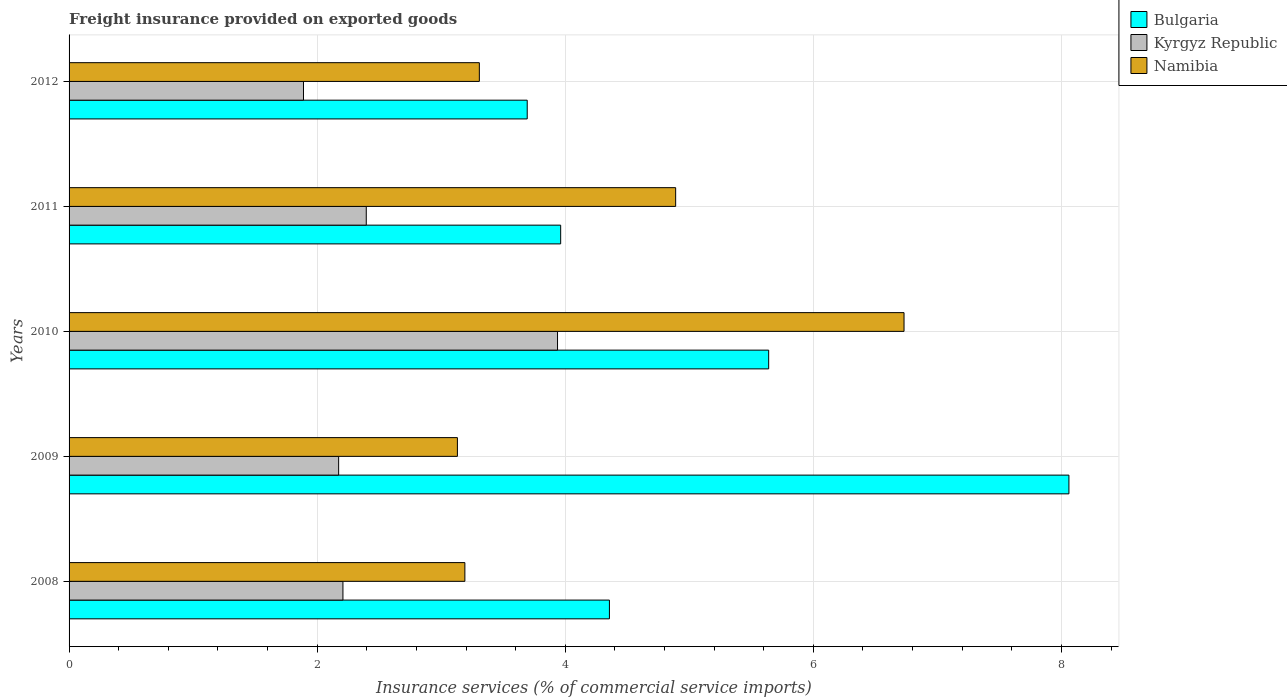How many groups of bars are there?
Keep it short and to the point. 5. Are the number of bars per tick equal to the number of legend labels?
Your answer should be very brief. Yes. Are the number of bars on each tick of the Y-axis equal?
Offer a terse response. Yes. How many bars are there on the 4th tick from the bottom?
Your answer should be very brief. 3. What is the freight insurance provided on exported goods in Namibia in 2011?
Provide a short and direct response. 4.89. Across all years, what is the maximum freight insurance provided on exported goods in Kyrgyz Republic?
Ensure brevity in your answer.  3.94. Across all years, what is the minimum freight insurance provided on exported goods in Bulgaria?
Your answer should be very brief. 3.69. In which year was the freight insurance provided on exported goods in Bulgaria maximum?
Your response must be concise. 2009. In which year was the freight insurance provided on exported goods in Bulgaria minimum?
Your answer should be compact. 2012. What is the total freight insurance provided on exported goods in Bulgaria in the graph?
Make the answer very short. 25.71. What is the difference between the freight insurance provided on exported goods in Kyrgyz Republic in 2010 and that in 2012?
Your answer should be compact. 2.05. What is the difference between the freight insurance provided on exported goods in Namibia in 2010 and the freight insurance provided on exported goods in Kyrgyz Republic in 2009?
Your response must be concise. 4.56. What is the average freight insurance provided on exported goods in Bulgaria per year?
Your answer should be very brief. 5.14. In the year 2011, what is the difference between the freight insurance provided on exported goods in Kyrgyz Republic and freight insurance provided on exported goods in Namibia?
Keep it short and to the point. -2.49. In how many years, is the freight insurance provided on exported goods in Namibia greater than 4.8 %?
Your response must be concise. 2. What is the ratio of the freight insurance provided on exported goods in Bulgaria in 2009 to that in 2011?
Provide a succinct answer. 2.03. Is the freight insurance provided on exported goods in Kyrgyz Republic in 2009 less than that in 2011?
Your answer should be very brief. Yes. Is the difference between the freight insurance provided on exported goods in Kyrgyz Republic in 2009 and 2012 greater than the difference between the freight insurance provided on exported goods in Namibia in 2009 and 2012?
Offer a very short reply. Yes. What is the difference between the highest and the second highest freight insurance provided on exported goods in Namibia?
Make the answer very short. 1.84. What is the difference between the highest and the lowest freight insurance provided on exported goods in Kyrgyz Republic?
Make the answer very short. 2.05. In how many years, is the freight insurance provided on exported goods in Bulgaria greater than the average freight insurance provided on exported goods in Bulgaria taken over all years?
Provide a short and direct response. 2. What does the 2nd bar from the bottom in 2012 represents?
Provide a short and direct response. Kyrgyz Republic. Is it the case that in every year, the sum of the freight insurance provided on exported goods in Bulgaria and freight insurance provided on exported goods in Kyrgyz Republic is greater than the freight insurance provided on exported goods in Namibia?
Give a very brief answer. Yes. How many years are there in the graph?
Give a very brief answer. 5. What is the difference between two consecutive major ticks on the X-axis?
Your answer should be very brief. 2. Are the values on the major ticks of X-axis written in scientific E-notation?
Your response must be concise. No. Where does the legend appear in the graph?
Make the answer very short. Top right. How are the legend labels stacked?
Provide a succinct answer. Vertical. What is the title of the graph?
Ensure brevity in your answer.  Freight insurance provided on exported goods. Does "Greenland" appear as one of the legend labels in the graph?
Ensure brevity in your answer.  No. What is the label or title of the X-axis?
Provide a short and direct response. Insurance services (% of commercial service imports). What is the label or title of the Y-axis?
Keep it short and to the point. Years. What is the Insurance services (% of commercial service imports) of Bulgaria in 2008?
Your answer should be compact. 4.36. What is the Insurance services (% of commercial service imports) of Kyrgyz Republic in 2008?
Make the answer very short. 2.21. What is the Insurance services (% of commercial service imports) in Namibia in 2008?
Provide a succinct answer. 3.19. What is the Insurance services (% of commercial service imports) of Bulgaria in 2009?
Keep it short and to the point. 8.06. What is the Insurance services (% of commercial service imports) in Kyrgyz Republic in 2009?
Offer a very short reply. 2.17. What is the Insurance services (% of commercial service imports) of Namibia in 2009?
Offer a very short reply. 3.13. What is the Insurance services (% of commercial service imports) of Bulgaria in 2010?
Your answer should be compact. 5.64. What is the Insurance services (% of commercial service imports) in Kyrgyz Republic in 2010?
Your response must be concise. 3.94. What is the Insurance services (% of commercial service imports) in Namibia in 2010?
Offer a terse response. 6.73. What is the Insurance services (% of commercial service imports) in Bulgaria in 2011?
Offer a very short reply. 3.96. What is the Insurance services (% of commercial service imports) in Kyrgyz Republic in 2011?
Offer a very short reply. 2.4. What is the Insurance services (% of commercial service imports) of Namibia in 2011?
Offer a very short reply. 4.89. What is the Insurance services (% of commercial service imports) in Bulgaria in 2012?
Offer a terse response. 3.69. What is the Insurance services (% of commercial service imports) in Kyrgyz Republic in 2012?
Provide a succinct answer. 1.89. What is the Insurance services (% of commercial service imports) of Namibia in 2012?
Your answer should be very brief. 3.31. Across all years, what is the maximum Insurance services (% of commercial service imports) of Bulgaria?
Provide a short and direct response. 8.06. Across all years, what is the maximum Insurance services (% of commercial service imports) of Kyrgyz Republic?
Give a very brief answer. 3.94. Across all years, what is the maximum Insurance services (% of commercial service imports) of Namibia?
Offer a terse response. 6.73. Across all years, what is the minimum Insurance services (% of commercial service imports) in Bulgaria?
Offer a terse response. 3.69. Across all years, what is the minimum Insurance services (% of commercial service imports) in Kyrgyz Republic?
Provide a succinct answer. 1.89. Across all years, what is the minimum Insurance services (% of commercial service imports) of Namibia?
Give a very brief answer. 3.13. What is the total Insurance services (% of commercial service imports) of Bulgaria in the graph?
Your answer should be compact. 25.71. What is the total Insurance services (% of commercial service imports) in Kyrgyz Republic in the graph?
Provide a short and direct response. 12.6. What is the total Insurance services (% of commercial service imports) in Namibia in the graph?
Provide a succinct answer. 21.25. What is the difference between the Insurance services (% of commercial service imports) in Bulgaria in 2008 and that in 2009?
Offer a terse response. -3.7. What is the difference between the Insurance services (% of commercial service imports) of Kyrgyz Republic in 2008 and that in 2009?
Give a very brief answer. 0.03. What is the difference between the Insurance services (% of commercial service imports) in Namibia in 2008 and that in 2009?
Provide a succinct answer. 0.06. What is the difference between the Insurance services (% of commercial service imports) in Bulgaria in 2008 and that in 2010?
Ensure brevity in your answer.  -1.28. What is the difference between the Insurance services (% of commercial service imports) of Kyrgyz Republic in 2008 and that in 2010?
Offer a terse response. -1.73. What is the difference between the Insurance services (% of commercial service imports) in Namibia in 2008 and that in 2010?
Provide a short and direct response. -3.54. What is the difference between the Insurance services (% of commercial service imports) in Bulgaria in 2008 and that in 2011?
Provide a short and direct response. 0.39. What is the difference between the Insurance services (% of commercial service imports) of Kyrgyz Republic in 2008 and that in 2011?
Provide a short and direct response. -0.19. What is the difference between the Insurance services (% of commercial service imports) in Namibia in 2008 and that in 2011?
Keep it short and to the point. -1.7. What is the difference between the Insurance services (% of commercial service imports) of Bulgaria in 2008 and that in 2012?
Keep it short and to the point. 0.66. What is the difference between the Insurance services (% of commercial service imports) in Kyrgyz Republic in 2008 and that in 2012?
Your response must be concise. 0.32. What is the difference between the Insurance services (% of commercial service imports) of Namibia in 2008 and that in 2012?
Your answer should be very brief. -0.12. What is the difference between the Insurance services (% of commercial service imports) in Bulgaria in 2009 and that in 2010?
Offer a terse response. 2.42. What is the difference between the Insurance services (% of commercial service imports) in Kyrgyz Republic in 2009 and that in 2010?
Give a very brief answer. -1.76. What is the difference between the Insurance services (% of commercial service imports) in Namibia in 2009 and that in 2010?
Provide a succinct answer. -3.6. What is the difference between the Insurance services (% of commercial service imports) of Bulgaria in 2009 and that in 2011?
Make the answer very short. 4.1. What is the difference between the Insurance services (% of commercial service imports) in Kyrgyz Republic in 2009 and that in 2011?
Make the answer very short. -0.22. What is the difference between the Insurance services (% of commercial service imports) of Namibia in 2009 and that in 2011?
Your answer should be very brief. -1.76. What is the difference between the Insurance services (% of commercial service imports) in Bulgaria in 2009 and that in 2012?
Ensure brevity in your answer.  4.37. What is the difference between the Insurance services (% of commercial service imports) of Kyrgyz Republic in 2009 and that in 2012?
Your answer should be very brief. 0.28. What is the difference between the Insurance services (% of commercial service imports) in Namibia in 2009 and that in 2012?
Offer a very short reply. -0.18. What is the difference between the Insurance services (% of commercial service imports) of Bulgaria in 2010 and that in 2011?
Offer a terse response. 1.68. What is the difference between the Insurance services (% of commercial service imports) of Kyrgyz Republic in 2010 and that in 2011?
Offer a terse response. 1.54. What is the difference between the Insurance services (% of commercial service imports) in Namibia in 2010 and that in 2011?
Keep it short and to the point. 1.84. What is the difference between the Insurance services (% of commercial service imports) of Bulgaria in 2010 and that in 2012?
Keep it short and to the point. 1.95. What is the difference between the Insurance services (% of commercial service imports) in Kyrgyz Republic in 2010 and that in 2012?
Offer a very short reply. 2.05. What is the difference between the Insurance services (% of commercial service imports) in Namibia in 2010 and that in 2012?
Your answer should be very brief. 3.42. What is the difference between the Insurance services (% of commercial service imports) in Bulgaria in 2011 and that in 2012?
Your answer should be compact. 0.27. What is the difference between the Insurance services (% of commercial service imports) of Kyrgyz Republic in 2011 and that in 2012?
Offer a terse response. 0.51. What is the difference between the Insurance services (% of commercial service imports) in Namibia in 2011 and that in 2012?
Offer a terse response. 1.58. What is the difference between the Insurance services (% of commercial service imports) of Bulgaria in 2008 and the Insurance services (% of commercial service imports) of Kyrgyz Republic in 2009?
Your response must be concise. 2.18. What is the difference between the Insurance services (% of commercial service imports) in Bulgaria in 2008 and the Insurance services (% of commercial service imports) in Namibia in 2009?
Your answer should be compact. 1.23. What is the difference between the Insurance services (% of commercial service imports) in Kyrgyz Republic in 2008 and the Insurance services (% of commercial service imports) in Namibia in 2009?
Provide a succinct answer. -0.92. What is the difference between the Insurance services (% of commercial service imports) of Bulgaria in 2008 and the Insurance services (% of commercial service imports) of Kyrgyz Republic in 2010?
Offer a terse response. 0.42. What is the difference between the Insurance services (% of commercial service imports) in Bulgaria in 2008 and the Insurance services (% of commercial service imports) in Namibia in 2010?
Offer a very short reply. -2.38. What is the difference between the Insurance services (% of commercial service imports) of Kyrgyz Republic in 2008 and the Insurance services (% of commercial service imports) of Namibia in 2010?
Offer a terse response. -4.52. What is the difference between the Insurance services (% of commercial service imports) of Bulgaria in 2008 and the Insurance services (% of commercial service imports) of Kyrgyz Republic in 2011?
Give a very brief answer. 1.96. What is the difference between the Insurance services (% of commercial service imports) of Bulgaria in 2008 and the Insurance services (% of commercial service imports) of Namibia in 2011?
Your answer should be compact. -0.53. What is the difference between the Insurance services (% of commercial service imports) in Kyrgyz Republic in 2008 and the Insurance services (% of commercial service imports) in Namibia in 2011?
Ensure brevity in your answer.  -2.68. What is the difference between the Insurance services (% of commercial service imports) of Bulgaria in 2008 and the Insurance services (% of commercial service imports) of Kyrgyz Republic in 2012?
Offer a very short reply. 2.47. What is the difference between the Insurance services (% of commercial service imports) of Bulgaria in 2008 and the Insurance services (% of commercial service imports) of Namibia in 2012?
Your answer should be very brief. 1.05. What is the difference between the Insurance services (% of commercial service imports) in Kyrgyz Republic in 2008 and the Insurance services (% of commercial service imports) in Namibia in 2012?
Offer a terse response. -1.1. What is the difference between the Insurance services (% of commercial service imports) in Bulgaria in 2009 and the Insurance services (% of commercial service imports) in Kyrgyz Republic in 2010?
Provide a short and direct response. 4.12. What is the difference between the Insurance services (% of commercial service imports) in Bulgaria in 2009 and the Insurance services (% of commercial service imports) in Namibia in 2010?
Provide a short and direct response. 1.33. What is the difference between the Insurance services (% of commercial service imports) of Kyrgyz Republic in 2009 and the Insurance services (% of commercial service imports) of Namibia in 2010?
Give a very brief answer. -4.56. What is the difference between the Insurance services (% of commercial service imports) in Bulgaria in 2009 and the Insurance services (% of commercial service imports) in Kyrgyz Republic in 2011?
Your answer should be very brief. 5.66. What is the difference between the Insurance services (% of commercial service imports) of Bulgaria in 2009 and the Insurance services (% of commercial service imports) of Namibia in 2011?
Provide a succinct answer. 3.17. What is the difference between the Insurance services (% of commercial service imports) in Kyrgyz Republic in 2009 and the Insurance services (% of commercial service imports) in Namibia in 2011?
Offer a very short reply. -2.72. What is the difference between the Insurance services (% of commercial service imports) in Bulgaria in 2009 and the Insurance services (% of commercial service imports) in Kyrgyz Republic in 2012?
Your answer should be very brief. 6.17. What is the difference between the Insurance services (% of commercial service imports) in Bulgaria in 2009 and the Insurance services (% of commercial service imports) in Namibia in 2012?
Your answer should be very brief. 4.75. What is the difference between the Insurance services (% of commercial service imports) in Kyrgyz Republic in 2009 and the Insurance services (% of commercial service imports) in Namibia in 2012?
Make the answer very short. -1.13. What is the difference between the Insurance services (% of commercial service imports) of Bulgaria in 2010 and the Insurance services (% of commercial service imports) of Kyrgyz Republic in 2011?
Ensure brevity in your answer.  3.24. What is the difference between the Insurance services (% of commercial service imports) of Bulgaria in 2010 and the Insurance services (% of commercial service imports) of Namibia in 2011?
Offer a terse response. 0.75. What is the difference between the Insurance services (% of commercial service imports) of Kyrgyz Republic in 2010 and the Insurance services (% of commercial service imports) of Namibia in 2011?
Offer a terse response. -0.95. What is the difference between the Insurance services (% of commercial service imports) in Bulgaria in 2010 and the Insurance services (% of commercial service imports) in Kyrgyz Republic in 2012?
Provide a succinct answer. 3.75. What is the difference between the Insurance services (% of commercial service imports) of Bulgaria in 2010 and the Insurance services (% of commercial service imports) of Namibia in 2012?
Make the answer very short. 2.33. What is the difference between the Insurance services (% of commercial service imports) of Kyrgyz Republic in 2010 and the Insurance services (% of commercial service imports) of Namibia in 2012?
Your response must be concise. 0.63. What is the difference between the Insurance services (% of commercial service imports) in Bulgaria in 2011 and the Insurance services (% of commercial service imports) in Kyrgyz Republic in 2012?
Offer a very short reply. 2.07. What is the difference between the Insurance services (% of commercial service imports) of Bulgaria in 2011 and the Insurance services (% of commercial service imports) of Namibia in 2012?
Your answer should be very brief. 0.66. What is the difference between the Insurance services (% of commercial service imports) in Kyrgyz Republic in 2011 and the Insurance services (% of commercial service imports) in Namibia in 2012?
Offer a terse response. -0.91. What is the average Insurance services (% of commercial service imports) of Bulgaria per year?
Provide a short and direct response. 5.14. What is the average Insurance services (% of commercial service imports) of Kyrgyz Republic per year?
Ensure brevity in your answer.  2.52. What is the average Insurance services (% of commercial service imports) in Namibia per year?
Your answer should be compact. 4.25. In the year 2008, what is the difference between the Insurance services (% of commercial service imports) in Bulgaria and Insurance services (% of commercial service imports) in Kyrgyz Republic?
Keep it short and to the point. 2.15. In the year 2008, what is the difference between the Insurance services (% of commercial service imports) in Bulgaria and Insurance services (% of commercial service imports) in Namibia?
Your answer should be very brief. 1.17. In the year 2008, what is the difference between the Insurance services (% of commercial service imports) in Kyrgyz Republic and Insurance services (% of commercial service imports) in Namibia?
Provide a short and direct response. -0.98. In the year 2009, what is the difference between the Insurance services (% of commercial service imports) in Bulgaria and Insurance services (% of commercial service imports) in Kyrgyz Republic?
Make the answer very short. 5.89. In the year 2009, what is the difference between the Insurance services (% of commercial service imports) in Bulgaria and Insurance services (% of commercial service imports) in Namibia?
Ensure brevity in your answer.  4.93. In the year 2009, what is the difference between the Insurance services (% of commercial service imports) in Kyrgyz Republic and Insurance services (% of commercial service imports) in Namibia?
Provide a succinct answer. -0.96. In the year 2010, what is the difference between the Insurance services (% of commercial service imports) of Bulgaria and Insurance services (% of commercial service imports) of Kyrgyz Republic?
Your answer should be very brief. 1.7. In the year 2010, what is the difference between the Insurance services (% of commercial service imports) of Bulgaria and Insurance services (% of commercial service imports) of Namibia?
Ensure brevity in your answer.  -1.09. In the year 2010, what is the difference between the Insurance services (% of commercial service imports) of Kyrgyz Republic and Insurance services (% of commercial service imports) of Namibia?
Provide a short and direct response. -2.79. In the year 2011, what is the difference between the Insurance services (% of commercial service imports) of Bulgaria and Insurance services (% of commercial service imports) of Kyrgyz Republic?
Offer a very short reply. 1.57. In the year 2011, what is the difference between the Insurance services (% of commercial service imports) in Bulgaria and Insurance services (% of commercial service imports) in Namibia?
Your answer should be very brief. -0.93. In the year 2011, what is the difference between the Insurance services (% of commercial service imports) of Kyrgyz Republic and Insurance services (% of commercial service imports) of Namibia?
Make the answer very short. -2.49. In the year 2012, what is the difference between the Insurance services (% of commercial service imports) in Bulgaria and Insurance services (% of commercial service imports) in Kyrgyz Republic?
Offer a terse response. 1.8. In the year 2012, what is the difference between the Insurance services (% of commercial service imports) of Bulgaria and Insurance services (% of commercial service imports) of Namibia?
Your answer should be compact. 0.39. In the year 2012, what is the difference between the Insurance services (% of commercial service imports) of Kyrgyz Republic and Insurance services (% of commercial service imports) of Namibia?
Offer a very short reply. -1.42. What is the ratio of the Insurance services (% of commercial service imports) of Bulgaria in 2008 to that in 2009?
Ensure brevity in your answer.  0.54. What is the ratio of the Insurance services (% of commercial service imports) in Kyrgyz Republic in 2008 to that in 2009?
Provide a succinct answer. 1.02. What is the ratio of the Insurance services (% of commercial service imports) in Namibia in 2008 to that in 2009?
Provide a short and direct response. 1.02. What is the ratio of the Insurance services (% of commercial service imports) of Bulgaria in 2008 to that in 2010?
Offer a terse response. 0.77. What is the ratio of the Insurance services (% of commercial service imports) in Kyrgyz Republic in 2008 to that in 2010?
Provide a succinct answer. 0.56. What is the ratio of the Insurance services (% of commercial service imports) in Namibia in 2008 to that in 2010?
Provide a short and direct response. 0.47. What is the ratio of the Insurance services (% of commercial service imports) of Bulgaria in 2008 to that in 2011?
Make the answer very short. 1.1. What is the ratio of the Insurance services (% of commercial service imports) of Kyrgyz Republic in 2008 to that in 2011?
Offer a terse response. 0.92. What is the ratio of the Insurance services (% of commercial service imports) in Namibia in 2008 to that in 2011?
Give a very brief answer. 0.65. What is the ratio of the Insurance services (% of commercial service imports) of Bulgaria in 2008 to that in 2012?
Give a very brief answer. 1.18. What is the ratio of the Insurance services (% of commercial service imports) of Kyrgyz Republic in 2008 to that in 2012?
Your answer should be compact. 1.17. What is the ratio of the Insurance services (% of commercial service imports) in Namibia in 2008 to that in 2012?
Your answer should be compact. 0.96. What is the ratio of the Insurance services (% of commercial service imports) in Bulgaria in 2009 to that in 2010?
Your answer should be compact. 1.43. What is the ratio of the Insurance services (% of commercial service imports) in Kyrgyz Republic in 2009 to that in 2010?
Keep it short and to the point. 0.55. What is the ratio of the Insurance services (% of commercial service imports) of Namibia in 2009 to that in 2010?
Make the answer very short. 0.47. What is the ratio of the Insurance services (% of commercial service imports) in Bulgaria in 2009 to that in 2011?
Make the answer very short. 2.03. What is the ratio of the Insurance services (% of commercial service imports) in Kyrgyz Republic in 2009 to that in 2011?
Your answer should be compact. 0.91. What is the ratio of the Insurance services (% of commercial service imports) of Namibia in 2009 to that in 2011?
Keep it short and to the point. 0.64. What is the ratio of the Insurance services (% of commercial service imports) of Bulgaria in 2009 to that in 2012?
Offer a terse response. 2.18. What is the ratio of the Insurance services (% of commercial service imports) of Kyrgyz Republic in 2009 to that in 2012?
Give a very brief answer. 1.15. What is the ratio of the Insurance services (% of commercial service imports) of Namibia in 2009 to that in 2012?
Your response must be concise. 0.95. What is the ratio of the Insurance services (% of commercial service imports) of Bulgaria in 2010 to that in 2011?
Your answer should be compact. 1.42. What is the ratio of the Insurance services (% of commercial service imports) in Kyrgyz Republic in 2010 to that in 2011?
Your response must be concise. 1.64. What is the ratio of the Insurance services (% of commercial service imports) of Namibia in 2010 to that in 2011?
Keep it short and to the point. 1.38. What is the ratio of the Insurance services (% of commercial service imports) of Bulgaria in 2010 to that in 2012?
Provide a short and direct response. 1.53. What is the ratio of the Insurance services (% of commercial service imports) of Kyrgyz Republic in 2010 to that in 2012?
Offer a terse response. 2.08. What is the ratio of the Insurance services (% of commercial service imports) in Namibia in 2010 to that in 2012?
Provide a short and direct response. 2.04. What is the ratio of the Insurance services (% of commercial service imports) of Bulgaria in 2011 to that in 2012?
Your answer should be very brief. 1.07. What is the ratio of the Insurance services (% of commercial service imports) of Kyrgyz Republic in 2011 to that in 2012?
Provide a short and direct response. 1.27. What is the ratio of the Insurance services (% of commercial service imports) of Namibia in 2011 to that in 2012?
Provide a short and direct response. 1.48. What is the difference between the highest and the second highest Insurance services (% of commercial service imports) of Bulgaria?
Keep it short and to the point. 2.42. What is the difference between the highest and the second highest Insurance services (% of commercial service imports) of Kyrgyz Republic?
Your answer should be compact. 1.54. What is the difference between the highest and the second highest Insurance services (% of commercial service imports) in Namibia?
Offer a very short reply. 1.84. What is the difference between the highest and the lowest Insurance services (% of commercial service imports) in Bulgaria?
Ensure brevity in your answer.  4.37. What is the difference between the highest and the lowest Insurance services (% of commercial service imports) in Kyrgyz Republic?
Provide a short and direct response. 2.05. What is the difference between the highest and the lowest Insurance services (% of commercial service imports) of Namibia?
Provide a succinct answer. 3.6. 